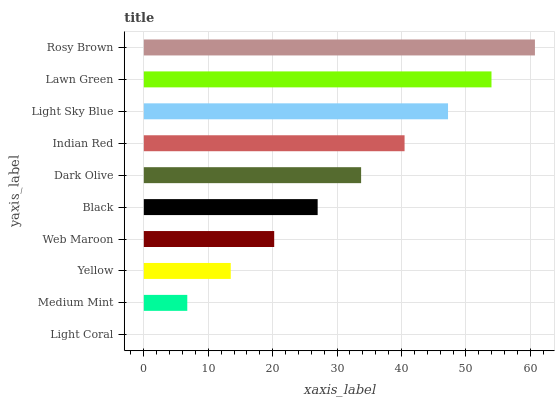Is Light Coral the minimum?
Answer yes or no. Yes. Is Rosy Brown the maximum?
Answer yes or no. Yes. Is Medium Mint the minimum?
Answer yes or no. No. Is Medium Mint the maximum?
Answer yes or no. No. Is Medium Mint greater than Light Coral?
Answer yes or no. Yes. Is Light Coral less than Medium Mint?
Answer yes or no. Yes. Is Light Coral greater than Medium Mint?
Answer yes or no. No. Is Medium Mint less than Light Coral?
Answer yes or no. No. Is Dark Olive the high median?
Answer yes or no. Yes. Is Black the low median?
Answer yes or no. Yes. Is Medium Mint the high median?
Answer yes or no. No. Is Yellow the low median?
Answer yes or no. No. 